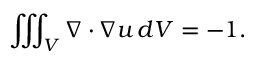<formula> <loc_0><loc_0><loc_500><loc_500>\iiint _ { V } \nabla \cdot \nabla u \, d V = - 1 .</formula> 